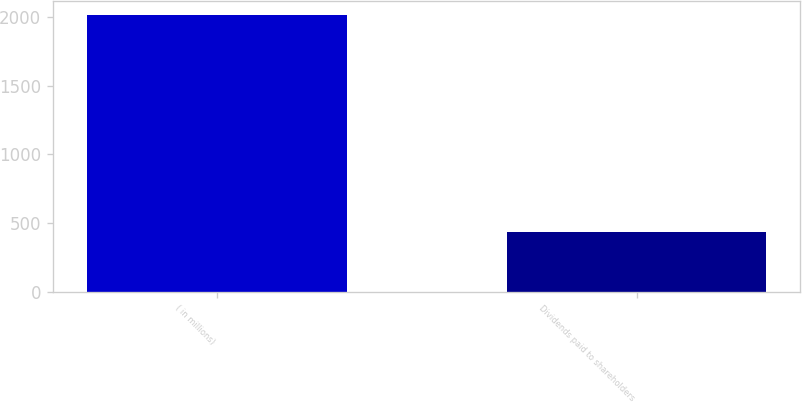Convert chart. <chart><loc_0><loc_0><loc_500><loc_500><bar_chart><fcel>( in millions)<fcel>Dividends paid to shareholders<nl><fcel>2017<fcel>434<nl></chart> 